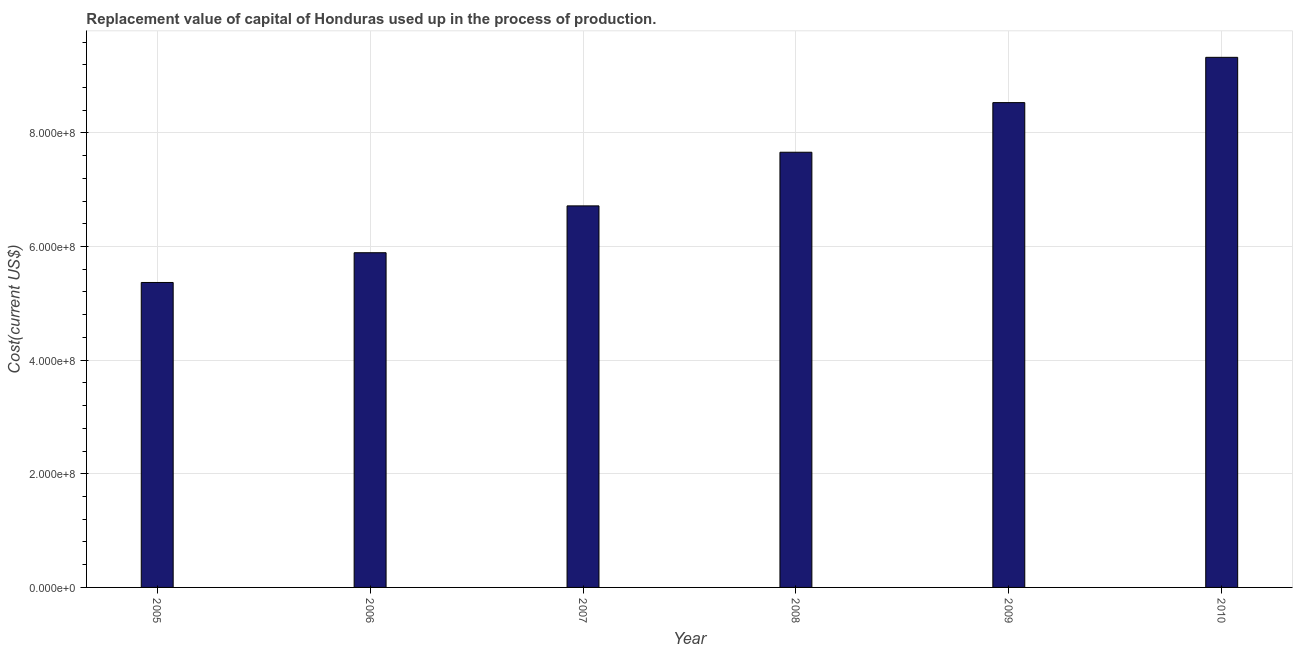What is the title of the graph?
Provide a succinct answer. Replacement value of capital of Honduras used up in the process of production. What is the label or title of the Y-axis?
Give a very brief answer. Cost(current US$). What is the consumption of fixed capital in 2006?
Make the answer very short. 5.89e+08. Across all years, what is the maximum consumption of fixed capital?
Offer a very short reply. 9.33e+08. Across all years, what is the minimum consumption of fixed capital?
Provide a succinct answer. 5.37e+08. In which year was the consumption of fixed capital maximum?
Offer a very short reply. 2010. In which year was the consumption of fixed capital minimum?
Offer a terse response. 2005. What is the sum of the consumption of fixed capital?
Make the answer very short. 4.35e+09. What is the difference between the consumption of fixed capital in 2005 and 2010?
Your response must be concise. -3.96e+08. What is the average consumption of fixed capital per year?
Your answer should be compact. 7.25e+08. What is the median consumption of fixed capital?
Ensure brevity in your answer.  7.19e+08. Do a majority of the years between 2008 and 2005 (inclusive) have consumption of fixed capital greater than 800000000 US$?
Provide a short and direct response. Yes. What is the ratio of the consumption of fixed capital in 2005 to that in 2009?
Your answer should be compact. 0.63. Is the consumption of fixed capital in 2007 less than that in 2010?
Offer a terse response. Yes. Is the difference between the consumption of fixed capital in 2008 and 2009 greater than the difference between any two years?
Give a very brief answer. No. What is the difference between the highest and the second highest consumption of fixed capital?
Provide a short and direct response. 7.97e+07. Is the sum of the consumption of fixed capital in 2005 and 2009 greater than the maximum consumption of fixed capital across all years?
Keep it short and to the point. Yes. What is the difference between the highest and the lowest consumption of fixed capital?
Offer a terse response. 3.96e+08. In how many years, is the consumption of fixed capital greater than the average consumption of fixed capital taken over all years?
Offer a terse response. 3. What is the Cost(current US$) of 2005?
Ensure brevity in your answer.  5.37e+08. What is the Cost(current US$) in 2006?
Provide a succinct answer. 5.89e+08. What is the Cost(current US$) in 2007?
Make the answer very short. 6.72e+08. What is the Cost(current US$) in 2008?
Offer a very short reply. 7.66e+08. What is the Cost(current US$) of 2009?
Keep it short and to the point. 8.53e+08. What is the Cost(current US$) of 2010?
Ensure brevity in your answer.  9.33e+08. What is the difference between the Cost(current US$) in 2005 and 2006?
Your answer should be very brief. -5.24e+07. What is the difference between the Cost(current US$) in 2005 and 2007?
Your response must be concise. -1.35e+08. What is the difference between the Cost(current US$) in 2005 and 2008?
Provide a succinct answer. -2.29e+08. What is the difference between the Cost(current US$) in 2005 and 2009?
Provide a short and direct response. -3.17e+08. What is the difference between the Cost(current US$) in 2005 and 2010?
Provide a succinct answer. -3.96e+08. What is the difference between the Cost(current US$) in 2006 and 2007?
Provide a short and direct response. -8.24e+07. What is the difference between the Cost(current US$) in 2006 and 2008?
Your response must be concise. -1.77e+08. What is the difference between the Cost(current US$) in 2006 and 2009?
Your answer should be very brief. -2.64e+08. What is the difference between the Cost(current US$) in 2006 and 2010?
Give a very brief answer. -3.44e+08. What is the difference between the Cost(current US$) in 2007 and 2008?
Your response must be concise. -9.44e+07. What is the difference between the Cost(current US$) in 2007 and 2009?
Your response must be concise. -1.82e+08. What is the difference between the Cost(current US$) in 2007 and 2010?
Offer a very short reply. -2.61e+08. What is the difference between the Cost(current US$) in 2008 and 2009?
Make the answer very short. -8.73e+07. What is the difference between the Cost(current US$) in 2008 and 2010?
Ensure brevity in your answer.  -1.67e+08. What is the difference between the Cost(current US$) in 2009 and 2010?
Keep it short and to the point. -7.97e+07. What is the ratio of the Cost(current US$) in 2005 to that in 2006?
Provide a short and direct response. 0.91. What is the ratio of the Cost(current US$) in 2005 to that in 2007?
Provide a succinct answer. 0.8. What is the ratio of the Cost(current US$) in 2005 to that in 2008?
Your response must be concise. 0.7. What is the ratio of the Cost(current US$) in 2005 to that in 2009?
Your answer should be very brief. 0.63. What is the ratio of the Cost(current US$) in 2005 to that in 2010?
Offer a very short reply. 0.57. What is the ratio of the Cost(current US$) in 2006 to that in 2007?
Give a very brief answer. 0.88. What is the ratio of the Cost(current US$) in 2006 to that in 2008?
Provide a succinct answer. 0.77. What is the ratio of the Cost(current US$) in 2006 to that in 2009?
Your response must be concise. 0.69. What is the ratio of the Cost(current US$) in 2006 to that in 2010?
Your answer should be compact. 0.63. What is the ratio of the Cost(current US$) in 2007 to that in 2008?
Ensure brevity in your answer.  0.88. What is the ratio of the Cost(current US$) in 2007 to that in 2009?
Offer a very short reply. 0.79. What is the ratio of the Cost(current US$) in 2007 to that in 2010?
Ensure brevity in your answer.  0.72. What is the ratio of the Cost(current US$) in 2008 to that in 2009?
Offer a terse response. 0.9. What is the ratio of the Cost(current US$) in 2008 to that in 2010?
Ensure brevity in your answer.  0.82. What is the ratio of the Cost(current US$) in 2009 to that in 2010?
Offer a very short reply. 0.92. 